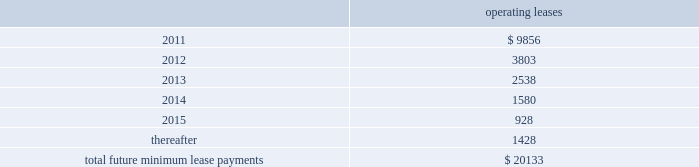Notes to consolidated financial statements 2014 ( continued ) note 14 2014commitments and contingencies leases we conduct a major part of our operations using leased facilities and equipment .
Many of these leases have renewal and purchase options and provide that we pay the cost of property taxes , insurance and maintenance .
Rent expense on all operating leases for fiscal 2010 , 2009 and 2008 was $ 32.8 million , $ 30.2 million , and $ 30.4 million , respectively .
Future minimum lease payments for all noncancelable leases at may 31 , 2010 were as follows : operating leases .
We are party to a number of claims and lawsuits incidental to our business .
In the opinion of management , the reasonably possible outcome of such matters , individually or in the aggregate , will not have a material adverse impact on our financial position , liquidity or results of operations .
We define operating taxes as tax contingencies that are unrelated to income taxes , such as sales and property taxes .
During the course of operations , we must interpret the meaning of various operating tax matters in the united states and in the foreign jurisdictions in which we do business .
Taxing authorities in those various jurisdictions may arrive at different interpretations of applicable tax laws and regulations as they relate to such operating tax matters , which could result in the payment of additional taxes in those jurisdictions .
As of may 31 , 2010 and 2009 we did not have a liability for operating tax items .
The amount of the liability is based on management 2019s best estimate given our history with similar matters and interpretations of current laws and regulations .
Bin/ica agreements in connection with our acquisition of merchant credit card operations of banks , we have entered into sponsorship or depository and processing agreements with certain of the banks .
These agreements allow us to use the banks 2019 identification numbers , referred to as bank identification number for visa transactions and interbank card association number for mastercard transactions , to clear credit card transactions through visa and mastercard .
Certain of such agreements contain financial covenants , and we were in compliance with all such covenants as of may 31 , 2010 .
On june 18 , 2010 , cibc provided notice that it will not renew its sponsorship with us for visa in canada after the initial ten year term .
As a result , their canadian visa sponsorship will expire in march 2011 .
We are .
What is the percentage change in rent expense from 2009 to 2010? 
Computations: (32.8 - 30.2)
Answer: 2.6. 